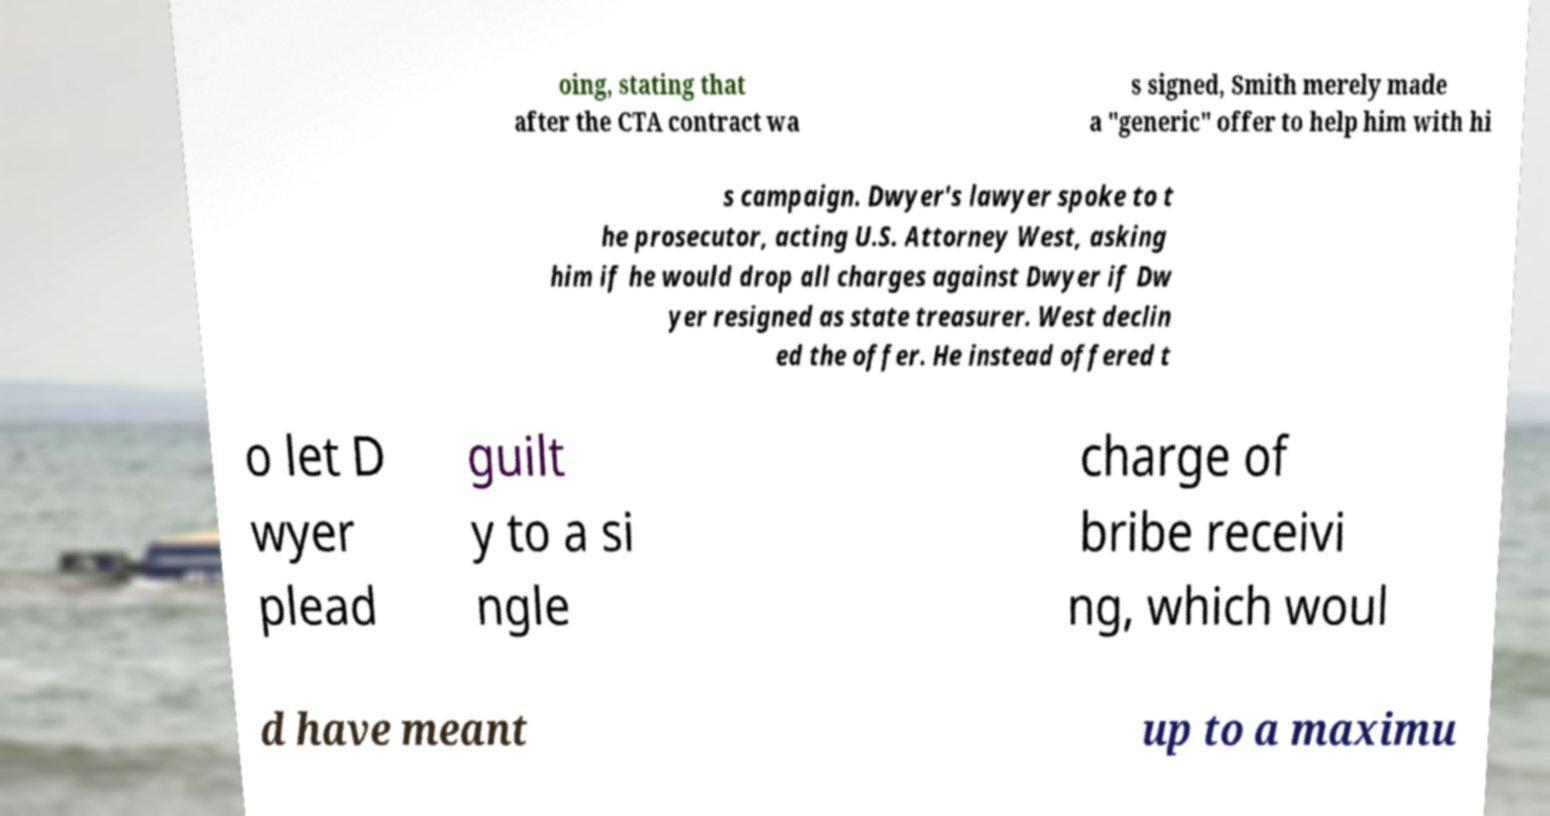Please identify and transcribe the text found in this image. oing, stating that after the CTA contract wa s signed, Smith merely made a "generic" offer to help him with hi s campaign. Dwyer's lawyer spoke to t he prosecutor, acting U.S. Attorney West, asking him if he would drop all charges against Dwyer if Dw yer resigned as state treasurer. West declin ed the offer. He instead offered t o let D wyer plead guilt y to a si ngle charge of bribe receivi ng, which woul d have meant up to a maximu 